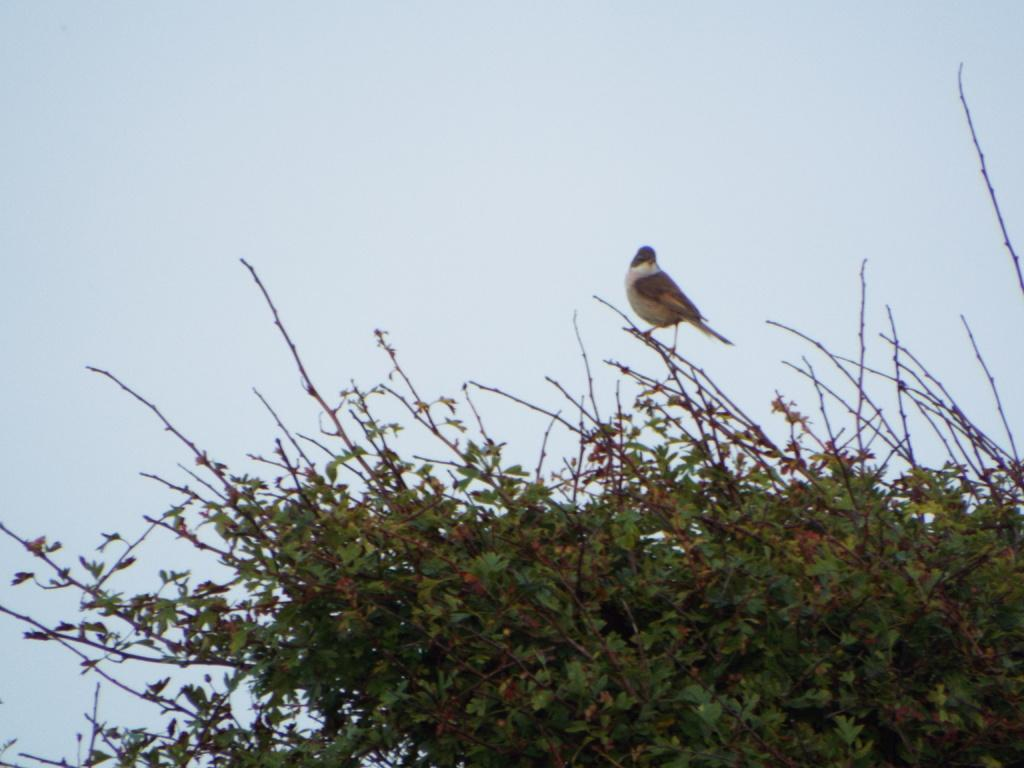What type of vegetation can be seen in the image? There are green color trees in the image. Are there any animals present in the image? Yes, a bird is present on the trees. What colors can be observed on the bird? The bird is in brown and white colors. What is the color of the background in the image? The background of the image is white. Can you tell me how many shops are visible in the image? There are no shops present in the image. Is the bird walking on the tree in the image? The image does not show the bird walking; it is perched on the tree. 